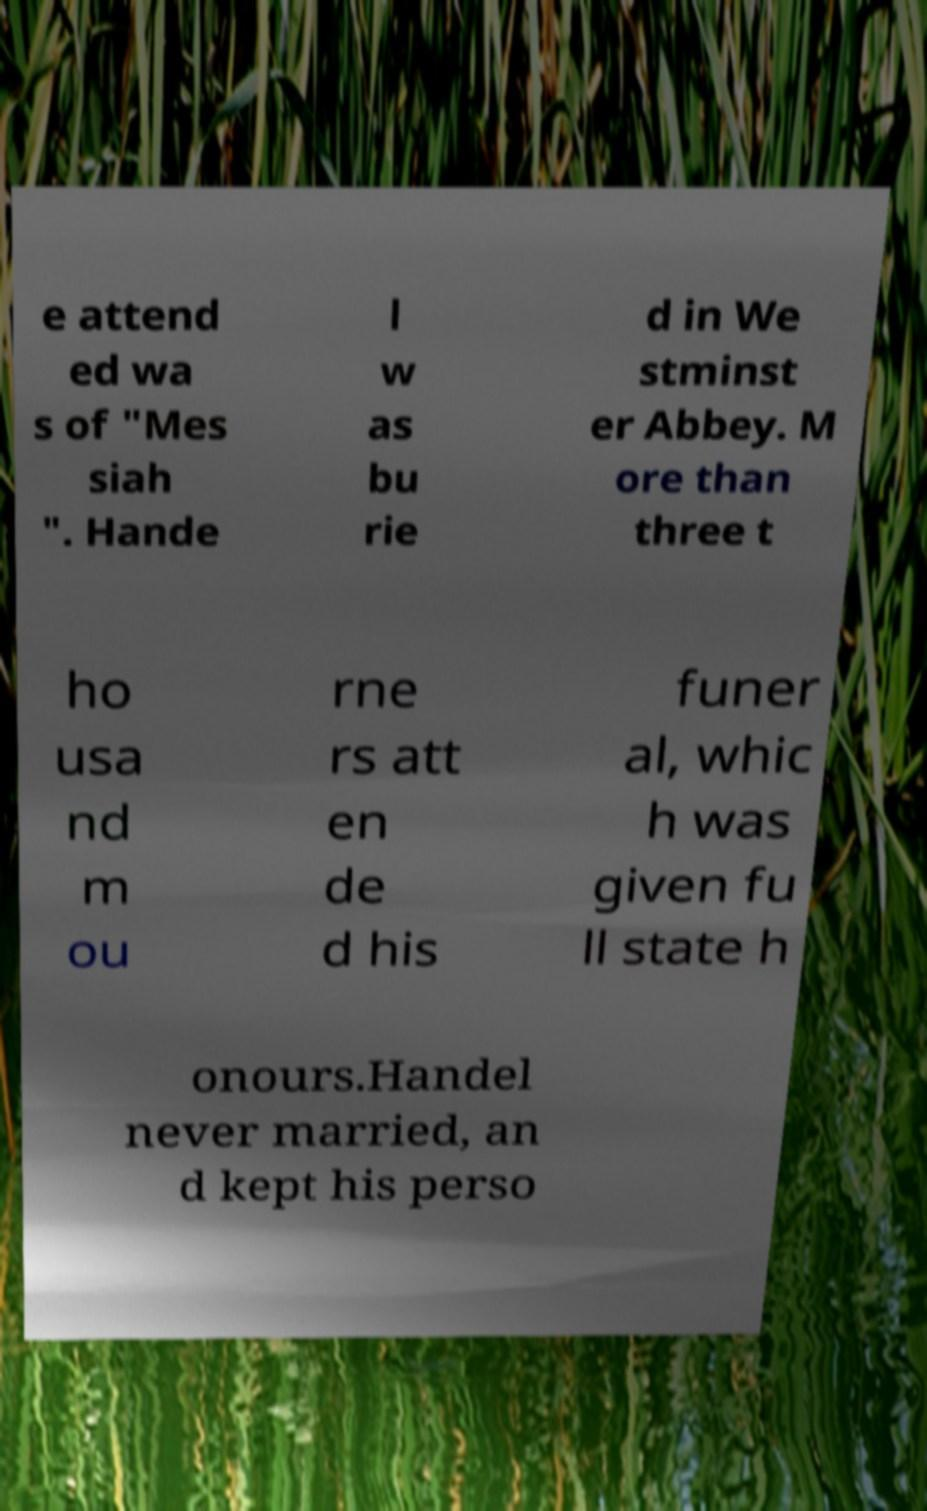What messages or text are displayed in this image? I need them in a readable, typed format. e attend ed wa s of "Mes siah ". Hande l w as bu rie d in We stminst er Abbey. M ore than three t ho usa nd m ou rne rs att en de d his funer al, whic h was given fu ll state h onours.Handel never married, an d kept his perso 